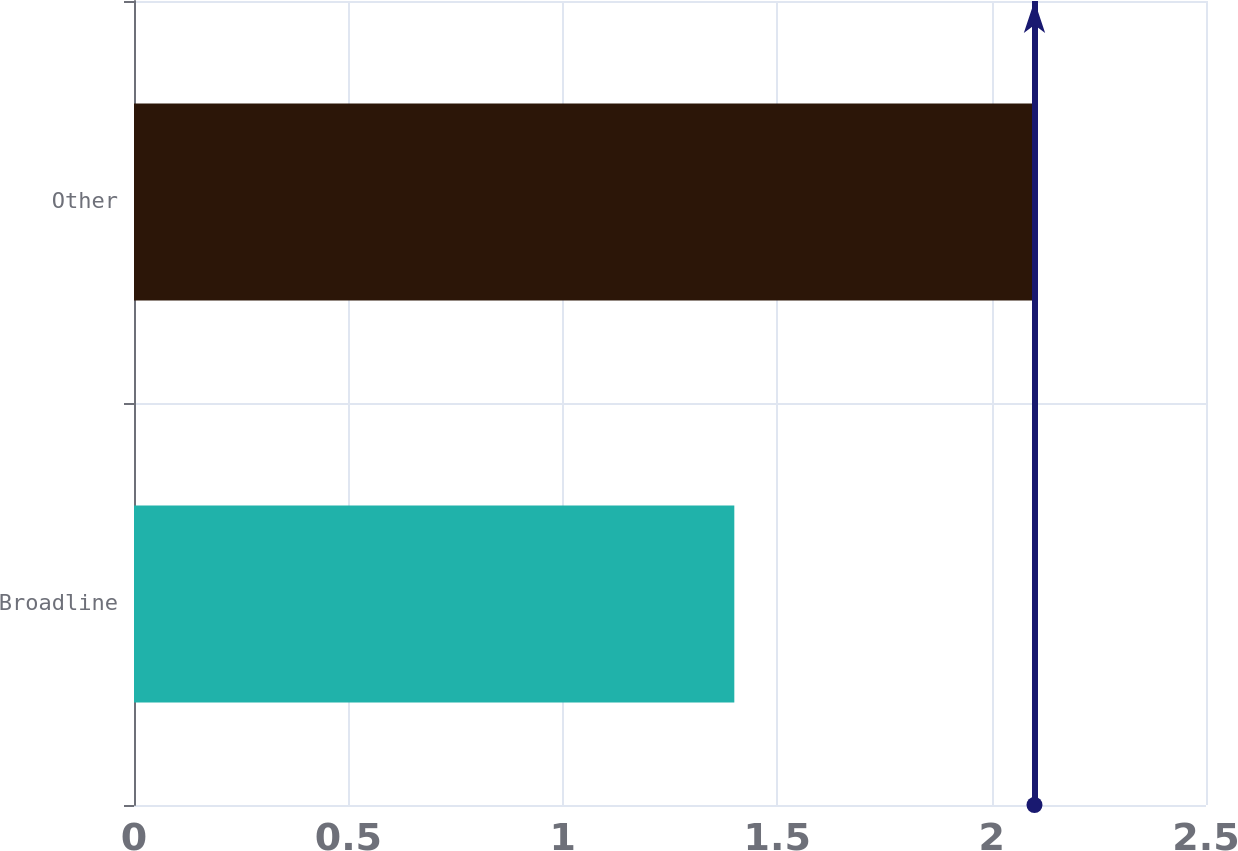Convert chart. <chart><loc_0><loc_0><loc_500><loc_500><bar_chart><fcel>Broadline<fcel>Other<nl><fcel>1.4<fcel>2.1<nl></chart> 